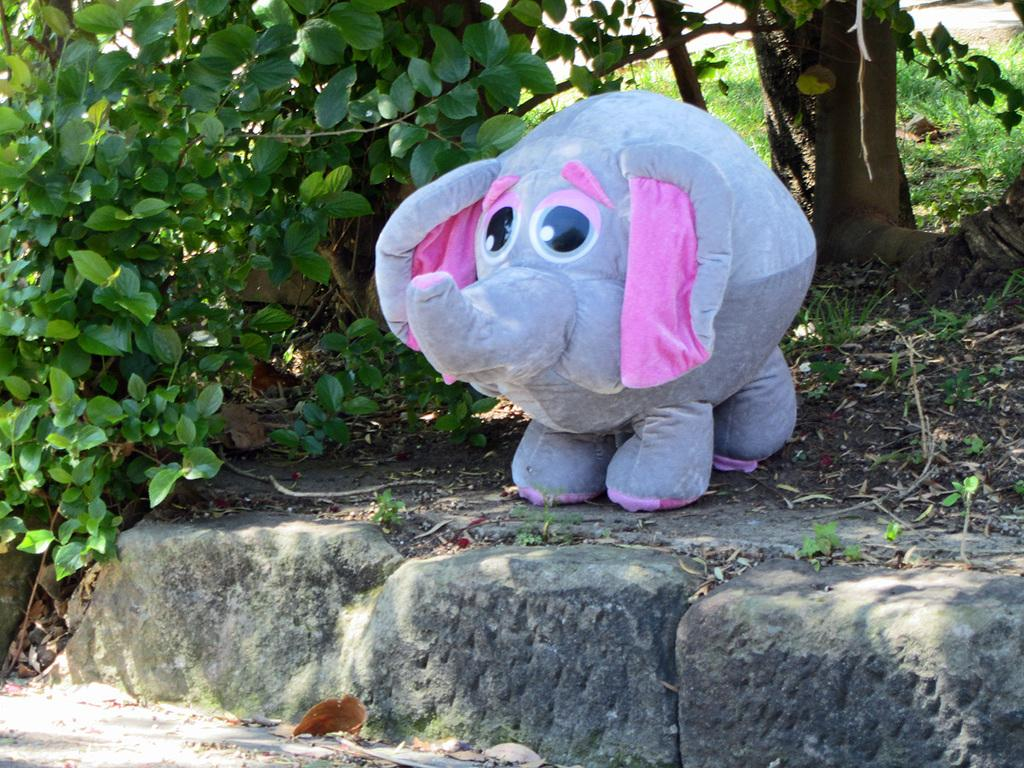What is the main subject in the middle of the image? There is a doll in the middle of the image. What can be seen in the background of the image? There are trees visible in the background of the image. What type of objects can be seen at the bottom of the image? There are stones visible at the bottom of the image. What type of collar can be seen on the doll in the image? There is no collar present on the doll in the image. Where is the desk located in the image? There is no desk present in the image. 